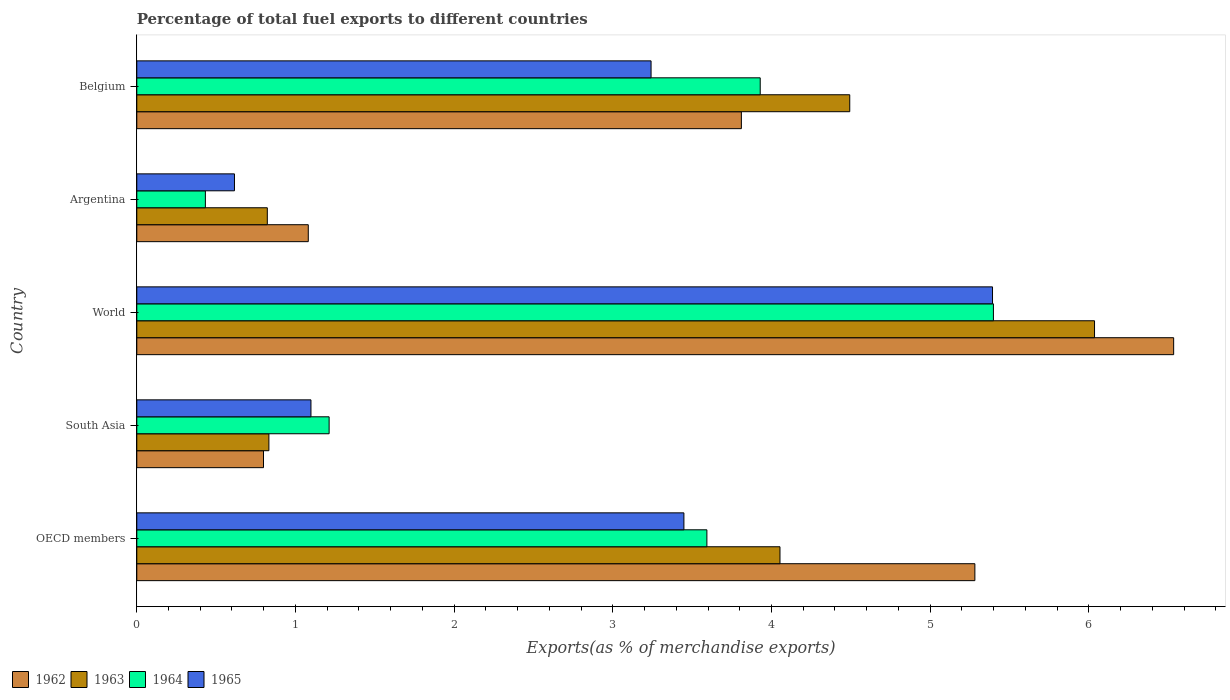Are the number of bars per tick equal to the number of legend labels?
Give a very brief answer. Yes. How many bars are there on the 3rd tick from the top?
Offer a terse response. 4. What is the percentage of exports to different countries in 1963 in OECD members?
Ensure brevity in your answer.  4.05. Across all countries, what is the maximum percentage of exports to different countries in 1964?
Ensure brevity in your answer.  5.4. Across all countries, what is the minimum percentage of exports to different countries in 1964?
Give a very brief answer. 0.43. In which country was the percentage of exports to different countries in 1965 minimum?
Give a very brief answer. Argentina. What is the total percentage of exports to different countries in 1963 in the graph?
Your answer should be very brief. 16.24. What is the difference between the percentage of exports to different countries in 1965 in Belgium and that in South Asia?
Offer a very short reply. 2.14. What is the difference between the percentage of exports to different countries in 1965 in South Asia and the percentage of exports to different countries in 1962 in OECD members?
Ensure brevity in your answer.  -4.18. What is the average percentage of exports to different countries in 1963 per country?
Offer a very short reply. 3.25. What is the difference between the percentage of exports to different countries in 1965 and percentage of exports to different countries in 1963 in World?
Give a very brief answer. -0.64. In how many countries, is the percentage of exports to different countries in 1965 greater than 2 %?
Keep it short and to the point. 3. What is the ratio of the percentage of exports to different countries in 1962 in Belgium to that in OECD members?
Keep it short and to the point. 0.72. What is the difference between the highest and the second highest percentage of exports to different countries in 1964?
Your answer should be compact. 1.47. What is the difference between the highest and the lowest percentage of exports to different countries in 1964?
Offer a very short reply. 4.97. Is the sum of the percentage of exports to different countries in 1965 in South Asia and World greater than the maximum percentage of exports to different countries in 1962 across all countries?
Make the answer very short. No. What does the 1st bar from the top in Argentina represents?
Keep it short and to the point. 1965. What does the 3rd bar from the bottom in Argentina represents?
Your response must be concise. 1964. Is it the case that in every country, the sum of the percentage of exports to different countries in 1962 and percentage of exports to different countries in 1963 is greater than the percentage of exports to different countries in 1964?
Provide a succinct answer. Yes. What is the difference between two consecutive major ticks on the X-axis?
Your response must be concise. 1. Are the values on the major ticks of X-axis written in scientific E-notation?
Your response must be concise. No. Does the graph contain any zero values?
Your answer should be very brief. No. Where does the legend appear in the graph?
Offer a very short reply. Bottom left. How many legend labels are there?
Keep it short and to the point. 4. What is the title of the graph?
Offer a very short reply. Percentage of total fuel exports to different countries. Does "1976" appear as one of the legend labels in the graph?
Your response must be concise. No. What is the label or title of the X-axis?
Offer a terse response. Exports(as % of merchandise exports). What is the Exports(as % of merchandise exports) of 1962 in OECD members?
Make the answer very short. 5.28. What is the Exports(as % of merchandise exports) in 1963 in OECD members?
Your response must be concise. 4.05. What is the Exports(as % of merchandise exports) of 1964 in OECD members?
Your answer should be very brief. 3.59. What is the Exports(as % of merchandise exports) in 1965 in OECD members?
Offer a terse response. 3.45. What is the Exports(as % of merchandise exports) of 1962 in South Asia?
Offer a terse response. 0.8. What is the Exports(as % of merchandise exports) in 1963 in South Asia?
Your answer should be very brief. 0.83. What is the Exports(as % of merchandise exports) in 1964 in South Asia?
Offer a terse response. 1.21. What is the Exports(as % of merchandise exports) in 1965 in South Asia?
Offer a very short reply. 1.1. What is the Exports(as % of merchandise exports) in 1962 in World?
Keep it short and to the point. 6.53. What is the Exports(as % of merchandise exports) in 1963 in World?
Your response must be concise. 6.04. What is the Exports(as % of merchandise exports) of 1964 in World?
Your answer should be compact. 5.4. What is the Exports(as % of merchandise exports) in 1965 in World?
Your answer should be compact. 5.39. What is the Exports(as % of merchandise exports) in 1962 in Argentina?
Provide a succinct answer. 1.08. What is the Exports(as % of merchandise exports) of 1963 in Argentina?
Give a very brief answer. 0.82. What is the Exports(as % of merchandise exports) of 1964 in Argentina?
Offer a very short reply. 0.43. What is the Exports(as % of merchandise exports) of 1965 in Argentina?
Provide a succinct answer. 0.62. What is the Exports(as % of merchandise exports) of 1962 in Belgium?
Give a very brief answer. 3.81. What is the Exports(as % of merchandise exports) in 1963 in Belgium?
Give a very brief answer. 4.49. What is the Exports(as % of merchandise exports) of 1964 in Belgium?
Your response must be concise. 3.93. What is the Exports(as % of merchandise exports) in 1965 in Belgium?
Provide a succinct answer. 3.24. Across all countries, what is the maximum Exports(as % of merchandise exports) in 1962?
Ensure brevity in your answer.  6.53. Across all countries, what is the maximum Exports(as % of merchandise exports) of 1963?
Provide a succinct answer. 6.04. Across all countries, what is the maximum Exports(as % of merchandise exports) in 1964?
Keep it short and to the point. 5.4. Across all countries, what is the maximum Exports(as % of merchandise exports) of 1965?
Give a very brief answer. 5.39. Across all countries, what is the minimum Exports(as % of merchandise exports) in 1962?
Your answer should be compact. 0.8. Across all countries, what is the minimum Exports(as % of merchandise exports) of 1963?
Your response must be concise. 0.82. Across all countries, what is the minimum Exports(as % of merchandise exports) of 1964?
Give a very brief answer. 0.43. Across all countries, what is the minimum Exports(as % of merchandise exports) of 1965?
Your answer should be very brief. 0.62. What is the total Exports(as % of merchandise exports) in 1962 in the graph?
Keep it short and to the point. 17.51. What is the total Exports(as % of merchandise exports) of 1963 in the graph?
Ensure brevity in your answer.  16.24. What is the total Exports(as % of merchandise exports) in 1964 in the graph?
Provide a succinct answer. 14.57. What is the total Exports(as % of merchandise exports) in 1965 in the graph?
Offer a very short reply. 13.8. What is the difference between the Exports(as % of merchandise exports) of 1962 in OECD members and that in South Asia?
Keep it short and to the point. 4.48. What is the difference between the Exports(as % of merchandise exports) in 1963 in OECD members and that in South Asia?
Keep it short and to the point. 3.22. What is the difference between the Exports(as % of merchandise exports) in 1964 in OECD members and that in South Asia?
Offer a terse response. 2.38. What is the difference between the Exports(as % of merchandise exports) in 1965 in OECD members and that in South Asia?
Your response must be concise. 2.35. What is the difference between the Exports(as % of merchandise exports) in 1962 in OECD members and that in World?
Give a very brief answer. -1.25. What is the difference between the Exports(as % of merchandise exports) in 1963 in OECD members and that in World?
Ensure brevity in your answer.  -1.98. What is the difference between the Exports(as % of merchandise exports) in 1964 in OECD members and that in World?
Make the answer very short. -1.81. What is the difference between the Exports(as % of merchandise exports) in 1965 in OECD members and that in World?
Offer a very short reply. -1.94. What is the difference between the Exports(as % of merchandise exports) in 1962 in OECD members and that in Argentina?
Your answer should be very brief. 4.2. What is the difference between the Exports(as % of merchandise exports) of 1963 in OECD members and that in Argentina?
Offer a very short reply. 3.23. What is the difference between the Exports(as % of merchandise exports) of 1964 in OECD members and that in Argentina?
Offer a very short reply. 3.16. What is the difference between the Exports(as % of merchandise exports) of 1965 in OECD members and that in Argentina?
Ensure brevity in your answer.  2.83. What is the difference between the Exports(as % of merchandise exports) of 1962 in OECD members and that in Belgium?
Offer a terse response. 1.47. What is the difference between the Exports(as % of merchandise exports) of 1963 in OECD members and that in Belgium?
Ensure brevity in your answer.  -0.44. What is the difference between the Exports(as % of merchandise exports) in 1964 in OECD members and that in Belgium?
Offer a terse response. -0.34. What is the difference between the Exports(as % of merchandise exports) of 1965 in OECD members and that in Belgium?
Your answer should be very brief. 0.21. What is the difference between the Exports(as % of merchandise exports) of 1962 in South Asia and that in World?
Offer a very short reply. -5.74. What is the difference between the Exports(as % of merchandise exports) of 1963 in South Asia and that in World?
Offer a very short reply. -5.2. What is the difference between the Exports(as % of merchandise exports) in 1964 in South Asia and that in World?
Provide a succinct answer. -4.19. What is the difference between the Exports(as % of merchandise exports) of 1965 in South Asia and that in World?
Ensure brevity in your answer.  -4.3. What is the difference between the Exports(as % of merchandise exports) in 1962 in South Asia and that in Argentina?
Provide a succinct answer. -0.28. What is the difference between the Exports(as % of merchandise exports) of 1963 in South Asia and that in Argentina?
Provide a succinct answer. 0.01. What is the difference between the Exports(as % of merchandise exports) in 1964 in South Asia and that in Argentina?
Offer a terse response. 0.78. What is the difference between the Exports(as % of merchandise exports) in 1965 in South Asia and that in Argentina?
Provide a short and direct response. 0.48. What is the difference between the Exports(as % of merchandise exports) of 1962 in South Asia and that in Belgium?
Your response must be concise. -3.01. What is the difference between the Exports(as % of merchandise exports) of 1963 in South Asia and that in Belgium?
Ensure brevity in your answer.  -3.66. What is the difference between the Exports(as % of merchandise exports) of 1964 in South Asia and that in Belgium?
Provide a succinct answer. -2.72. What is the difference between the Exports(as % of merchandise exports) of 1965 in South Asia and that in Belgium?
Your response must be concise. -2.14. What is the difference between the Exports(as % of merchandise exports) in 1962 in World and that in Argentina?
Offer a very short reply. 5.45. What is the difference between the Exports(as % of merchandise exports) of 1963 in World and that in Argentina?
Keep it short and to the point. 5.21. What is the difference between the Exports(as % of merchandise exports) in 1964 in World and that in Argentina?
Your answer should be very brief. 4.97. What is the difference between the Exports(as % of merchandise exports) of 1965 in World and that in Argentina?
Your response must be concise. 4.78. What is the difference between the Exports(as % of merchandise exports) of 1962 in World and that in Belgium?
Ensure brevity in your answer.  2.72. What is the difference between the Exports(as % of merchandise exports) of 1963 in World and that in Belgium?
Keep it short and to the point. 1.54. What is the difference between the Exports(as % of merchandise exports) in 1964 in World and that in Belgium?
Provide a succinct answer. 1.47. What is the difference between the Exports(as % of merchandise exports) of 1965 in World and that in Belgium?
Ensure brevity in your answer.  2.15. What is the difference between the Exports(as % of merchandise exports) of 1962 in Argentina and that in Belgium?
Keep it short and to the point. -2.73. What is the difference between the Exports(as % of merchandise exports) of 1963 in Argentina and that in Belgium?
Your response must be concise. -3.67. What is the difference between the Exports(as % of merchandise exports) of 1964 in Argentina and that in Belgium?
Your response must be concise. -3.5. What is the difference between the Exports(as % of merchandise exports) of 1965 in Argentina and that in Belgium?
Give a very brief answer. -2.63. What is the difference between the Exports(as % of merchandise exports) of 1962 in OECD members and the Exports(as % of merchandise exports) of 1963 in South Asia?
Your answer should be compact. 4.45. What is the difference between the Exports(as % of merchandise exports) of 1962 in OECD members and the Exports(as % of merchandise exports) of 1964 in South Asia?
Your answer should be very brief. 4.07. What is the difference between the Exports(as % of merchandise exports) of 1962 in OECD members and the Exports(as % of merchandise exports) of 1965 in South Asia?
Ensure brevity in your answer.  4.18. What is the difference between the Exports(as % of merchandise exports) of 1963 in OECD members and the Exports(as % of merchandise exports) of 1964 in South Asia?
Offer a terse response. 2.84. What is the difference between the Exports(as % of merchandise exports) of 1963 in OECD members and the Exports(as % of merchandise exports) of 1965 in South Asia?
Ensure brevity in your answer.  2.96. What is the difference between the Exports(as % of merchandise exports) of 1964 in OECD members and the Exports(as % of merchandise exports) of 1965 in South Asia?
Your answer should be compact. 2.5. What is the difference between the Exports(as % of merchandise exports) of 1962 in OECD members and the Exports(as % of merchandise exports) of 1963 in World?
Your answer should be very brief. -0.75. What is the difference between the Exports(as % of merchandise exports) of 1962 in OECD members and the Exports(as % of merchandise exports) of 1964 in World?
Your answer should be very brief. -0.12. What is the difference between the Exports(as % of merchandise exports) of 1962 in OECD members and the Exports(as % of merchandise exports) of 1965 in World?
Your answer should be compact. -0.11. What is the difference between the Exports(as % of merchandise exports) in 1963 in OECD members and the Exports(as % of merchandise exports) in 1964 in World?
Offer a terse response. -1.35. What is the difference between the Exports(as % of merchandise exports) in 1963 in OECD members and the Exports(as % of merchandise exports) in 1965 in World?
Provide a short and direct response. -1.34. What is the difference between the Exports(as % of merchandise exports) in 1964 in OECD members and the Exports(as % of merchandise exports) in 1965 in World?
Your response must be concise. -1.8. What is the difference between the Exports(as % of merchandise exports) in 1962 in OECD members and the Exports(as % of merchandise exports) in 1963 in Argentina?
Offer a very short reply. 4.46. What is the difference between the Exports(as % of merchandise exports) of 1962 in OECD members and the Exports(as % of merchandise exports) of 1964 in Argentina?
Ensure brevity in your answer.  4.85. What is the difference between the Exports(as % of merchandise exports) in 1962 in OECD members and the Exports(as % of merchandise exports) in 1965 in Argentina?
Offer a terse response. 4.67. What is the difference between the Exports(as % of merchandise exports) of 1963 in OECD members and the Exports(as % of merchandise exports) of 1964 in Argentina?
Keep it short and to the point. 3.62. What is the difference between the Exports(as % of merchandise exports) of 1963 in OECD members and the Exports(as % of merchandise exports) of 1965 in Argentina?
Your response must be concise. 3.44. What is the difference between the Exports(as % of merchandise exports) in 1964 in OECD members and the Exports(as % of merchandise exports) in 1965 in Argentina?
Provide a succinct answer. 2.98. What is the difference between the Exports(as % of merchandise exports) of 1962 in OECD members and the Exports(as % of merchandise exports) of 1963 in Belgium?
Your response must be concise. 0.79. What is the difference between the Exports(as % of merchandise exports) of 1962 in OECD members and the Exports(as % of merchandise exports) of 1964 in Belgium?
Offer a very short reply. 1.35. What is the difference between the Exports(as % of merchandise exports) in 1962 in OECD members and the Exports(as % of merchandise exports) in 1965 in Belgium?
Provide a short and direct response. 2.04. What is the difference between the Exports(as % of merchandise exports) of 1963 in OECD members and the Exports(as % of merchandise exports) of 1964 in Belgium?
Keep it short and to the point. 0.12. What is the difference between the Exports(as % of merchandise exports) in 1963 in OECD members and the Exports(as % of merchandise exports) in 1965 in Belgium?
Offer a very short reply. 0.81. What is the difference between the Exports(as % of merchandise exports) in 1964 in OECD members and the Exports(as % of merchandise exports) in 1965 in Belgium?
Give a very brief answer. 0.35. What is the difference between the Exports(as % of merchandise exports) of 1962 in South Asia and the Exports(as % of merchandise exports) of 1963 in World?
Offer a terse response. -5.24. What is the difference between the Exports(as % of merchandise exports) in 1962 in South Asia and the Exports(as % of merchandise exports) in 1964 in World?
Offer a very short reply. -4.6. What is the difference between the Exports(as % of merchandise exports) in 1962 in South Asia and the Exports(as % of merchandise exports) in 1965 in World?
Your answer should be very brief. -4.59. What is the difference between the Exports(as % of merchandise exports) of 1963 in South Asia and the Exports(as % of merchandise exports) of 1964 in World?
Provide a succinct answer. -4.57. What is the difference between the Exports(as % of merchandise exports) in 1963 in South Asia and the Exports(as % of merchandise exports) in 1965 in World?
Your answer should be compact. -4.56. What is the difference between the Exports(as % of merchandise exports) of 1964 in South Asia and the Exports(as % of merchandise exports) of 1965 in World?
Give a very brief answer. -4.18. What is the difference between the Exports(as % of merchandise exports) in 1962 in South Asia and the Exports(as % of merchandise exports) in 1963 in Argentina?
Ensure brevity in your answer.  -0.02. What is the difference between the Exports(as % of merchandise exports) in 1962 in South Asia and the Exports(as % of merchandise exports) in 1964 in Argentina?
Your answer should be very brief. 0.37. What is the difference between the Exports(as % of merchandise exports) of 1962 in South Asia and the Exports(as % of merchandise exports) of 1965 in Argentina?
Provide a short and direct response. 0.18. What is the difference between the Exports(as % of merchandise exports) in 1963 in South Asia and the Exports(as % of merchandise exports) in 1964 in Argentina?
Offer a very short reply. 0.4. What is the difference between the Exports(as % of merchandise exports) of 1963 in South Asia and the Exports(as % of merchandise exports) of 1965 in Argentina?
Provide a succinct answer. 0.22. What is the difference between the Exports(as % of merchandise exports) in 1964 in South Asia and the Exports(as % of merchandise exports) in 1965 in Argentina?
Ensure brevity in your answer.  0.6. What is the difference between the Exports(as % of merchandise exports) in 1962 in South Asia and the Exports(as % of merchandise exports) in 1963 in Belgium?
Give a very brief answer. -3.69. What is the difference between the Exports(as % of merchandise exports) in 1962 in South Asia and the Exports(as % of merchandise exports) in 1964 in Belgium?
Make the answer very short. -3.13. What is the difference between the Exports(as % of merchandise exports) of 1962 in South Asia and the Exports(as % of merchandise exports) of 1965 in Belgium?
Your response must be concise. -2.44. What is the difference between the Exports(as % of merchandise exports) in 1963 in South Asia and the Exports(as % of merchandise exports) in 1964 in Belgium?
Offer a very short reply. -3.1. What is the difference between the Exports(as % of merchandise exports) in 1963 in South Asia and the Exports(as % of merchandise exports) in 1965 in Belgium?
Make the answer very short. -2.41. What is the difference between the Exports(as % of merchandise exports) in 1964 in South Asia and the Exports(as % of merchandise exports) in 1965 in Belgium?
Give a very brief answer. -2.03. What is the difference between the Exports(as % of merchandise exports) of 1962 in World and the Exports(as % of merchandise exports) of 1963 in Argentina?
Offer a terse response. 5.71. What is the difference between the Exports(as % of merchandise exports) of 1962 in World and the Exports(as % of merchandise exports) of 1964 in Argentina?
Provide a succinct answer. 6.1. What is the difference between the Exports(as % of merchandise exports) in 1962 in World and the Exports(as % of merchandise exports) in 1965 in Argentina?
Offer a terse response. 5.92. What is the difference between the Exports(as % of merchandise exports) in 1963 in World and the Exports(as % of merchandise exports) in 1964 in Argentina?
Offer a very short reply. 5.6. What is the difference between the Exports(as % of merchandise exports) in 1963 in World and the Exports(as % of merchandise exports) in 1965 in Argentina?
Your response must be concise. 5.42. What is the difference between the Exports(as % of merchandise exports) of 1964 in World and the Exports(as % of merchandise exports) of 1965 in Argentina?
Make the answer very short. 4.78. What is the difference between the Exports(as % of merchandise exports) in 1962 in World and the Exports(as % of merchandise exports) in 1963 in Belgium?
Provide a succinct answer. 2.04. What is the difference between the Exports(as % of merchandise exports) of 1962 in World and the Exports(as % of merchandise exports) of 1964 in Belgium?
Ensure brevity in your answer.  2.61. What is the difference between the Exports(as % of merchandise exports) in 1962 in World and the Exports(as % of merchandise exports) in 1965 in Belgium?
Offer a terse response. 3.29. What is the difference between the Exports(as % of merchandise exports) in 1963 in World and the Exports(as % of merchandise exports) in 1964 in Belgium?
Your response must be concise. 2.11. What is the difference between the Exports(as % of merchandise exports) in 1963 in World and the Exports(as % of merchandise exports) in 1965 in Belgium?
Your answer should be compact. 2.79. What is the difference between the Exports(as % of merchandise exports) in 1964 in World and the Exports(as % of merchandise exports) in 1965 in Belgium?
Keep it short and to the point. 2.16. What is the difference between the Exports(as % of merchandise exports) in 1962 in Argentina and the Exports(as % of merchandise exports) in 1963 in Belgium?
Make the answer very short. -3.41. What is the difference between the Exports(as % of merchandise exports) of 1962 in Argentina and the Exports(as % of merchandise exports) of 1964 in Belgium?
Provide a short and direct response. -2.85. What is the difference between the Exports(as % of merchandise exports) of 1962 in Argentina and the Exports(as % of merchandise exports) of 1965 in Belgium?
Give a very brief answer. -2.16. What is the difference between the Exports(as % of merchandise exports) in 1963 in Argentina and the Exports(as % of merchandise exports) in 1964 in Belgium?
Give a very brief answer. -3.11. What is the difference between the Exports(as % of merchandise exports) in 1963 in Argentina and the Exports(as % of merchandise exports) in 1965 in Belgium?
Provide a short and direct response. -2.42. What is the difference between the Exports(as % of merchandise exports) in 1964 in Argentina and the Exports(as % of merchandise exports) in 1965 in Belgium?
Your answer should be compact. -2.81. What is the average Exports(as % of merchandise exports) of 1962 per country?
Offer a very short reply. 3.5. What is the average Exports(as % of merchandise exports) in 1963 per country?
Offer a terse response. 3.25. What is the average Exports(as % of merchandise exports) in 1964 per country?
Offer a terse response. 2.91. What is the average Exports(as % of merchandise exports) in 1965 per country?
Provide a short and direct response. 2.76. What is the difference between the Exports(as % of merchandise exports) in 1962 and Exports(as % of merchandise exports) in 1963 in OECD members?
Ensure brevity in your answer.  1.23. What is the difference between the Exports(as % of merchandise exports) in 1962 and Exports(as % of merchandise exports) in 1964 in OECD members?
Provide a short and direct response. 1.69. What is the difference between the Exports(as % of merchandise exports) of 1962 and Exports(as % of merchandise exports) of 1965 in OECD members?
Make the answer very short. 1.83. What is the difference between the Exports(as % of merchandise exports) in 1963 and Exports(as % of merchandise exports) in 1964 in OECD members?
Your answer should be very brief. 0.46. What is the difference between the Exports(as % of merchandise exports) of 1963 and Exports(as % of merchandise exports) of 1965 in OECD members?
Your answer should be very brief. 0.61. What is the difference between the Exports(as % of merchandise exports) in 1964 and Exports(as % of merchandise exports) in 1965 in OECD members?
Make the answer very short. 0.14. What is the difference between the Exports(as % of merchandise exports) in 1962 and Exports(as % of merchandise exports) in 1963 in South Asia?
Provide a short and direct response. -0.03. What is the difference between the Exports(as % of merchandise exports) of 1962 and Exports(as % of merchandise exports) of 1964 in South Asia?
Offer a terse response. -0.41. What is the difference between the Exports(as % of merchandise exports) of 1962 and Exports(as % of merchandise exports) of 1965 in South Asia?
Make the answer very short. -0.3. What is the difference between the Exports(as % of merchandise exports) of 1963 and Exports(as % of merchandise exports) of 1964 in South Asia?
Offer a very short reply. -0.38. What is the difference between the Exports(as % of merchandise exports) of 1963 and Exports(as % of merchandise exports) of 1965 in South Asia?
Offer a terse response. -0.27. What is the difference between the Exports(as % of merchandise exports) in 1964 and Exports(as % of merchandise exports) in 1965 in South Asia?
Keep it short and to the point. 0.11. What is the difference between the Exports(as % of merchandise exports) in 1962 and Exports(as % of merchandise exports) in 1963 in World?
Ensure brevity in your answer.  0.5. What is the difference between the Exports(as % of merchandise exports) in 1962 and Exports(as % of merchandise exports) in 1964 in World?
Offer a very short reply. 1.14. What is the difference between the Exports(as % of merchandise exports) of 1962 and Exports(as % of merchandise exports) of 1965 in World?
Your answer should be compact. 1.14. What is the difference between the Exports(as % of merchandise exports) in 1963 and Exports(as % of merchandise exports) in 1964 in World?
Your answer should be compact. 0.64. What is the difference between the Exports(as % of merchandise exports) of 1963 and Exports(as % of merchandise exports) of 1965 in World?
Your answer should be very brief. 0.64. What is the difference between the Exports(as % of merchandise exports) of 1964 and Exports(as % of merchandise exports) of 1965 in World?
Make the answer very short. 0.01. What is the difference between the Exports(as % of merchandise exports) in 1962 and Exports(as % of merchandise exports) in 1963 in Argentina?
Provide a succinct answer. 0.26. What is the difference between the Exports(as % of merchandise exports) of 1962 and Exports(as % of merchandise exports) of 1964 in Argentina?
Provide a succinct answer. 0.65. What is the difference between the Exports(as % of merchandise exports) of 1962 and Exports(as % of merchandise exports) of 1965 in Argentina?
Give a very brief answer. 0.47. What is the difference between the Exports(as % of merchandise exports) in 1963 and Exports(as % of merchandise exports) in 1964 in Argentina?
Your answer should be very brief. 0.39. What is the difference between the Exports(as % of merchandise exports) in 1963 and Exports(as % of merchandise exports) in 1965 in Argentina?
Your response must be concise. 0.21. What is the difference between the Exports(as % of merchandise exports) of 1964 and Exports(as % of merchandise exports) of 1965 in Argentina?
Make the answer very short. -0.18. What is the difference between the Exports(as % of merchandise exports) in 1962 and Exports(as % of merchandise exports) in 1963 in Belgium?
Offer a very short reply. -0.68. What is the difference between the Exports(as % of merchandise exports) in 1962 and Exports(as % of merchandise exports) in 1964 in Belgium?
Provide a succinct answer. -0.12. What is the difference between the Exports(as % of merchandise exports) of 1962 and Exports(as % of merchandise exports) of 1965 in Belgium?
Your response must be concise. 0.57. What is the difference between the Exports(as % of merchandise exports) in 1963 and Exports(as % of merchandise exports) in 1964 in Belgium?
Offer a very short reply. 0.56. What is the difference between the Exports(as % of merchandise exports) in 1963 and Exports(as % of merchandise exports) in 1965 in Belgium?
Make the answer very short. 1.25. What is the difference between the Exports(as % of merchandise exports) in 1964 and Exports(as % of merchandise exports) in 1965 in Belgium?
Ensure brevity in your answer.  0.69. What is the ratio of the Exports(as % of merchandise exports) of 1962 in OECD members to that in South Asia?
Ensure brevity in your answer.  6.61. What is the ratio of the Exports(as % of merchandise exports) in 1963 in OECD members to that in South Asia?
Ensure brevity in your answer.  4.87. What is the ratio of the Exports(as % of merchandise exports) in 1964 in OECD members to that in South Asia?
Ensure brevity in your answer.  2.96. What is the ratio of the Exports(as % of merchandise exports) in 1965 in OECD members to that in South Asia?
Provide a succinct answer. 3.14. What is the ratio of the Exports(as % of merchandise exports) of 1962 in OECD members to that in World?
Provide a succinct answer. 0.81. What is the ratio of the Exports(as % of merchandise exports) of 1963 in OECD members to that in World?
Ensure brevity in your answer.  0.67. What is the ratio of the Exports(as % of merchandise exports) of 1964 in OECD members to that in World?
Provide a succinct answer. 0.67. What is the ratio of the Exports(as % of merchandise exports) of 1965 in OECD members to that in World?
Your answer should be compact. 0.64. What is the ratio of the Exports(as % of merchandise exports) of 1962 in OECD members to that in Argentina?
Your answer should be very brief. 4.89. What is the ratio of the Exports(as % of merchandise exports) of 1963 in OECD members to that in Argentina?
Your answer should be compact. 4.93. What is the ratio of the Exports(as % of merchandise exports) of 1964 in OECD members to that in Argentina?
Give a very brief answer. 8.31. What is the ratio of the Exports(as % of merchandise exports) of 1965 in OECD members to that in Argentina?
Your response must be concise. 5.6. What is the ratio of the Exports(as % of merchandise exports) in 1962 in OECD members to that in Belgium?
Offer a terse response. 1.39. What is the ratio of the Exports(as % of merchandise exports) of 1963 in OECD members to that in Belgium?
Make the answer very short. 0.9. What is the ratio of the Exports(as % of merchandise exports) in 1964 in OECD members to that in Belgium?
Make the answer very short. 0.91. What is the ratio of the Exports(as % of merchandise exports) of 1965 in OECD members to that in Belgium?
Your answer should be very brief. 1.06. What is the ratio of the Exports(as % of merchandise exports) of 1962 in South Asia to that in World?
Give a very brief answer. 0.12. What is the ratio of the Exports(as % of merchandise exports) in 1963 in South Asia to that in World?
Offer a terse response. 0.14. What is the ratio of the Exports(as % of merchandise exports) of 1964 in South Asia to that in World?
Keep it short and to the point. 0.22. What is the ratio of the Exports(as % of merchandise exports) of 1965 in South Asia to that in World?
Provide a short and direct response. 0.2. What is the ratio of the Exports(as % of merchandise exports) in 1962 in South Asia to that in Argentina?
Your answer should be very brief. 0.74. What is the ratio of the Exports(as % of merchandise exports) of 1963 in South Asia to that in Argentina?
Your answer should be compact. 1.01. What is the ratio of the Exports(as % of merchandise exports) of 1964 in South Asia to that in Argentina?
Provide a short and direct response. 2.8. What is the ratio of the Exports(as % of merchandise exports) in 1965 in South Asia to that in Argentina?
Provide a short and direct response. 1.78. What is the ratio of the Exports(as % of merchandise exports) in 1962 in South Asia to that in Belgium?
Keep it short and to the point. 0.21. What is the ratio of the Exports(as % of merchandise exports) in 1963 in South Asia to that in Belgium?
Keep it short and to the point. 0.19. What is the ratio of the Exports(as % of merchandise exports) in 1964 in South Asia to that in Belgium?
Offer a terse response. 0.31. What is the ratio of the Exports(as % of merchandise exports) in 1965 in South Asia to that in Belgium?
Give a very brief answer. 0.34. What is the ratio of the Exports(as % of merchandise exports) in 1962 in World to that in Argentina?
Provide a short and direct response. 6.05. What is the ratio of the Exports(as % of merchandise exports) in 1963 in World to that in Argentina?
Give a very brief answer. 7.34. What is the ratio of the Exports(as % of merchandise exports) of 1964 in World to that in Argentina?
Provide a short and direct response. 12.49. What is the ratio of the Exports(as % of merchandise exports) in 1965 in World to that in Argentina?
Your response must be concise. 8.76. What is the ratio of the Exports(as % of merchandise exports) in 1962 in World to that in Belgium?
Your response must be concise. 1.72. What is the ratio of the Exports(as % of merchandise exports) in 1963 in World to that in Belgium?
Give a very brief answer. 1.34. What is the ratio of the Exports(as % of merchandise exports) in 1964 in World to that in Belgium?
Provide a succinct answer. 1.37. What is the ratio of the Exports(as % of merchandise exports) of 1965 in World to that in Belgium?
Give a very brief answer. 1.66. What is the ratio of the Exports(as % of merchandise exports) of 1962 in Argentina to that in Belgium?
Provide a short and direct response. 0.28. What is the ratio of the Exports(as % of merchandise exports) of 1963 in Argentina to that in Belgium?
Make the answer very short. 0.18. What is the ratio of the Exports(as % of merchandise exports) of 1964 in Argentina to that in Belgium?
Your answer should be very brief. 0.11. What is the ratio of the Exports(as % of merchandise exports) in 1965 in Argentina to that in Belgium?
Give a very brief answer. 0.19. What is the difference between the highest and the second highest Exports(as % of merchandise exports) in 1962?
Provide a short and direct response. 1.25. What is the difference between the highest and the second highest Exports(as % of merchandise exports) of 1963?
Provide a short and direct response. 1.54. What is the difference between the highest and the second highest Exports(as % of merchandise exports) in 1964?
Give a very brief answer. 1.47. What is the difference between the highest and the second highest Exports(as % of merchandise exports) of 1965?
Offer a terse response. 1.94. What is the difference between the highest and the lowest Exports(as % of merchandise exports) in 1962?
Ensure brevity in your answer.  5.74. What is the difference between the highest and the lowest Exports(as % of merchandise exports) of 1963?
Offer a very short reply. 5.21. What is the difference between the highest and the lowest Exports(as % of merchandise exports) of 1964?
Provide a succinct answer. 4.97. What is the difference between the highest and the lowest Exports(as % of merchandise exports) in 1965?
Ensure brevity in your answer.  4.78. 